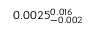<formula> <loc_0><loc_0><loc_500><loc_500>0 . 0 0 2 5 _ { - 0 . 0 0 2 } ^ { 0 . 0 1 6 }</formula> 